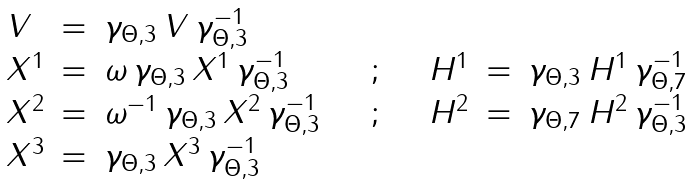Convert formula to latex. <formula><loc_0><loc_0><loc_500><loc_500>\begin{array} { l l l l l l l } V & = & \gamma _ { \Theta , 3 } \, V \, \gamma _ { \Theta , 3 } ^ { - 1 } & & & & \\ X ^ { 1 } & = & \omega \, \gamma _ { \Theta , 3 } \, X ^ { 1 } \, \gamma _ { \Theta , 3 } ^ { - 1 } & \quad ; \quad & H ^ { 1 } & = & \gamma _ { \Theta , 3 } \, H ^ { 1 } \, \gamma _ { \Theta , 7 } ^ { - 1 } \\ X ^ { 2 } & = & \omega ^ { - 1 } \, \gamma _ { \Theta , 3 } \, X ^ { 2 } \, \gamma _ { \Theta , 3 } ^ { - 1 } & \quad ; \quad & H ^ { 2 } & = & \gamma _ { \Theta , 7 } \, H ^ { 2 } \, \gamma _ { \Theta , 3 } ^ { - 1 } \\ X ^ { 3 } & = & \gamma _ { \Theta , 3 } \, X ^ { 3 } \, \gamma _ { \Theta , 3 } ^ { - 1 } & & & & \end{array}</formula> 